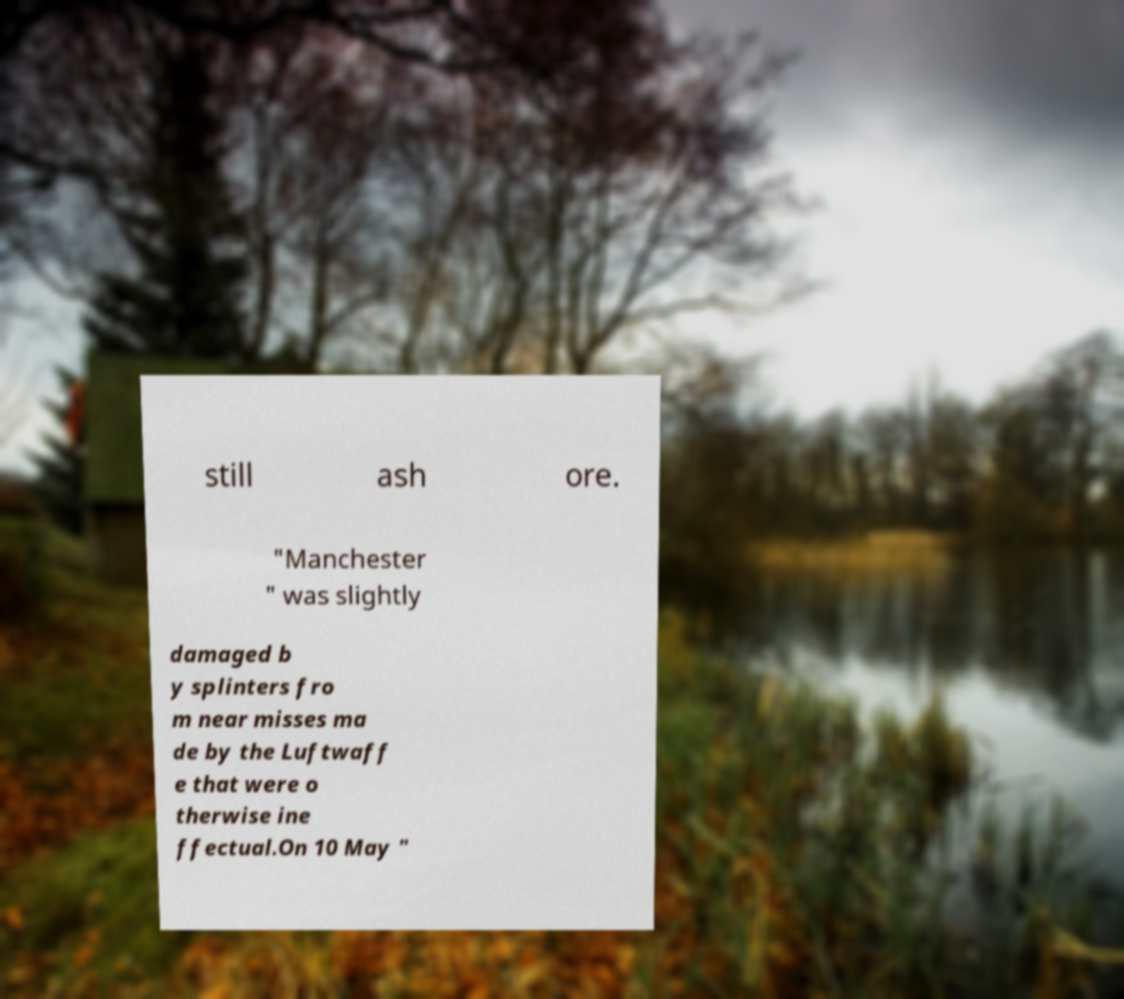Please identify and transcribe the text found in this image. still ash ore. "Manchester " was slightly damaged b y splinters fro m near misses ma de by the Luftwaff e that were o therwise ine ffectual.On 10 May " 